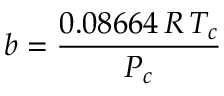Convert formula to latex. <formula><loc_0><loc_0><loc_500><loc_500>b = { \frac { 0 . 0 8 6 6 4 \, R \, T _ { c } } { P _ { c } } }</formula> 